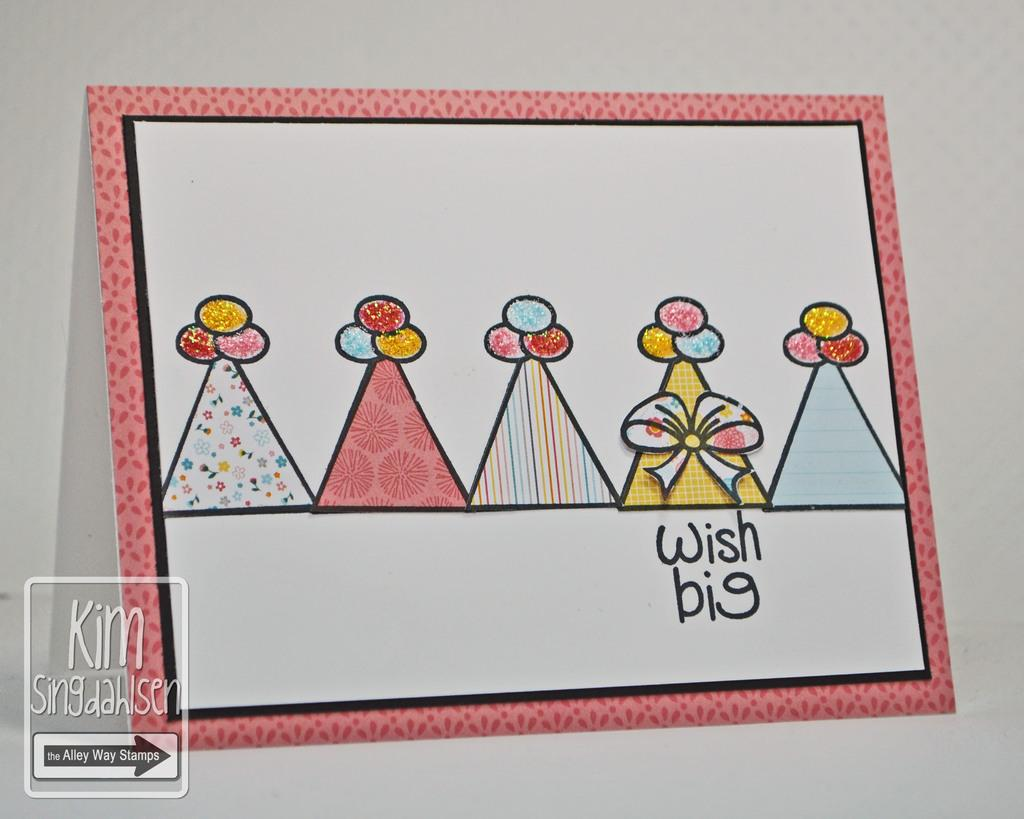Provide a one-sentence caption for the provided image. A card with five party hats and the words wish big on it. 